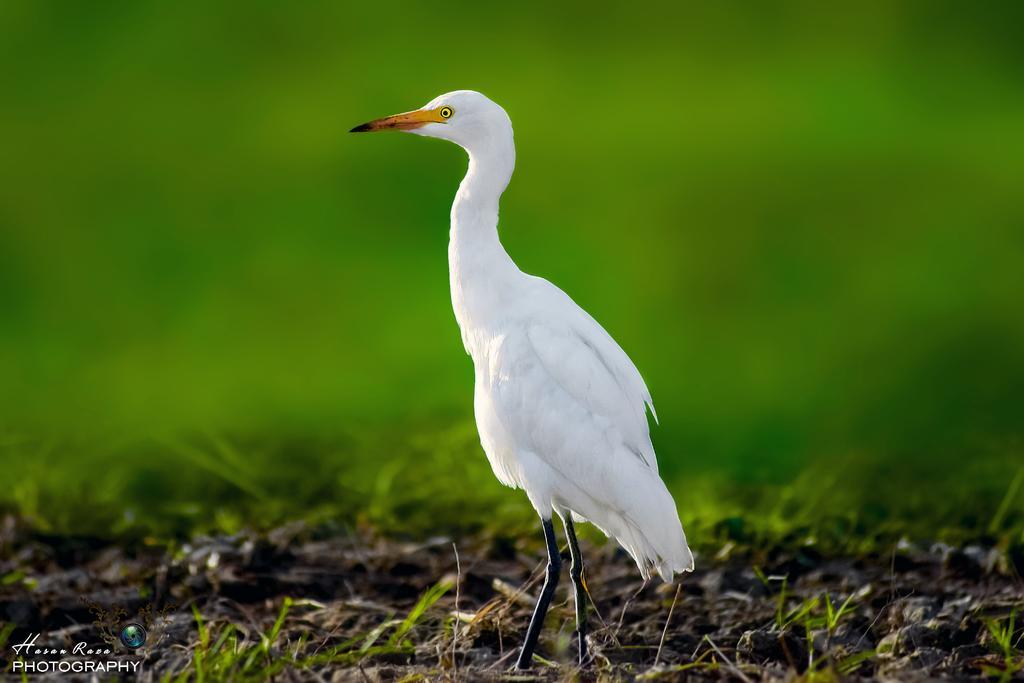Please provide a concise description of this image. There is a white color crane standing on the ground on which, there is grass. And the background is blurred. 